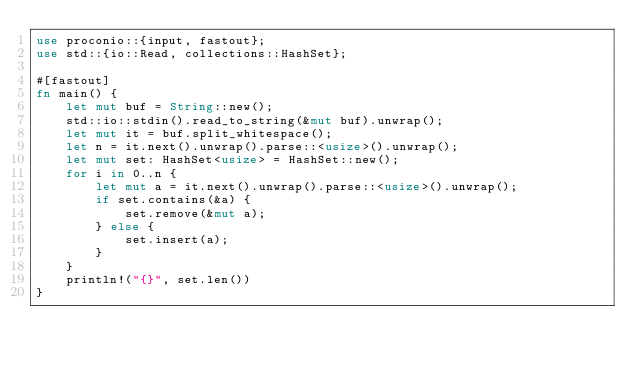Convert code to text. <code><loc_0><loc_0><loc_500><loc_500><_Rust_>use proconio::{input, fastout};
use std::{io::Read, collections::HashSet};

#[fastout]
fn main() {
    let mut buf = String::new();
    std::io::stdin().read_to_string(&mut buf).unwrap();
    let mut it = buf.split_whitespace();
    let n = it.next().unwrap().parse::<usize>().unwrap();
    let mut set: HashSet<usize> = HashSet::new();
    for i in 0..n {
        let mut a = it.next().unwrap().parse::<usize>().unwrap();
        if set.contains(&a) {
            set.remove(&mut a);
        } else {
            set.insert(a);
        }
    }
    println!("{}", set.len())
}
</code> 